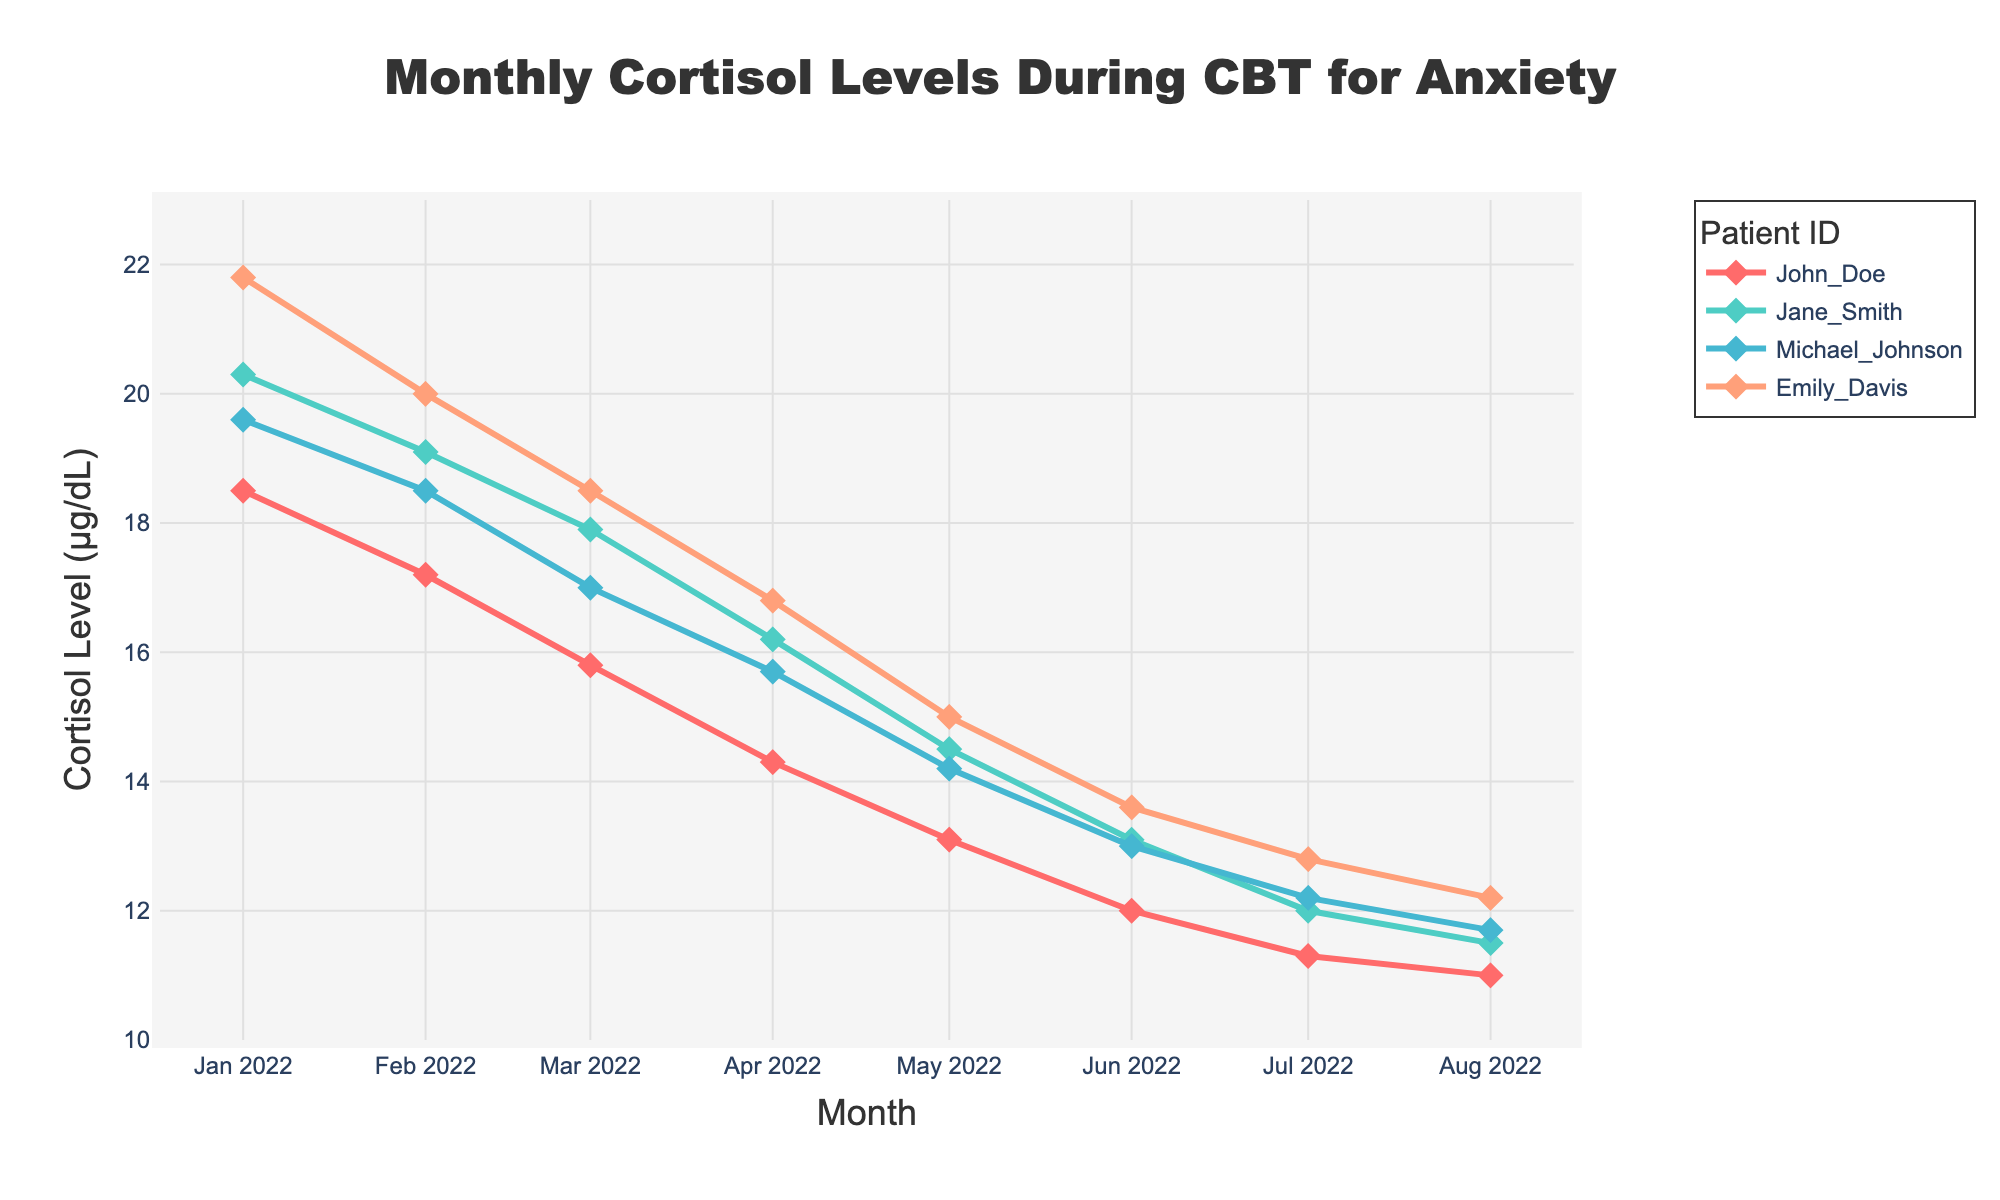What is the title of the figure? The title is usually displayed at the top of the figure. In this case, it is clearly labeled in the code provided.
Answer: Monthly Cortisol Levels During CBT for Anxiety What is the maximum cortisol level recorded in January? Look at the data points for January across all patients and identify the highest value.
Answer: 21.8 µg/dL Which patient shows the greatest decrease in cortisol levels from January to August? Calculate the difference between January and August cortisol levels for each patient. The patient with the highest difference shows the greatest decrease. For John Doe: 18.5 - 11, Jane Smith: 20.3 - 11.5, Michael Johnson: 19.6 - 11.7, and Emily Davis: 21.8 - 12.2. John Doe has the greatest decrease (18.5 - 11 = 7.5).
Answer: John Doe On average, how much does Jane Smith’s cortisol level decrease each month? Calculate the difference in Jane Smith's cortisol levels between the starting and ending months (January to August), then divide by the number of months (8). Total decrease is 20.3 - 11.5 = 8.8. Average decrease per month is 8.8 / 8 = 1.1.
Answer: 1.1 µg/dL Between which two months did Michael Johnson experience the most significant change in cortisol levels? Check the month-to-month changes in Michael Johnson's cortisol levels and identify the largest absolute difference. Largest change: February to March (18.5 - 17 = 1.5).
Answer: February and March How does Emily Davis's cortisol level in July compare to her cortisol level in January? Compare the values for Emily Davis in January and July. January: 21.8, July: 12.8. Emily Davis's cortisol level decreased from January to July.
Answer: It decreased Which month shows the largest average cortisol level among all patients? Calculate the average cortisol level for each month across all patients, then identify the highest average. January has the highest average: (18.5 + 20.3 + 19.6 + 21.8) / 4 = 20.05 µg/dL.
Answer: January What is the pattern of cortisol levels over time for John Doe? Observe the trend line for John Doe. His cortisol levels show a continuous decline from January to August.
Answer: Continuous decline By how much did Michael Johnson's cortisol levels change in total from January to August? Calculate the absolute change from January to August for Michael Johnson. His levels went from 19.6 in January to 11.7 in August. 19.6 - 11.7 = 7.9 µg/dL.
Answer: 7.9 µg/dL What is the general trend in cortisol levels for all patients during the eight months? Look at the overall trend lines for all patients. Cortisol levels generally decrease over the treatment period from January to August.
Answer: Generally decreasing 